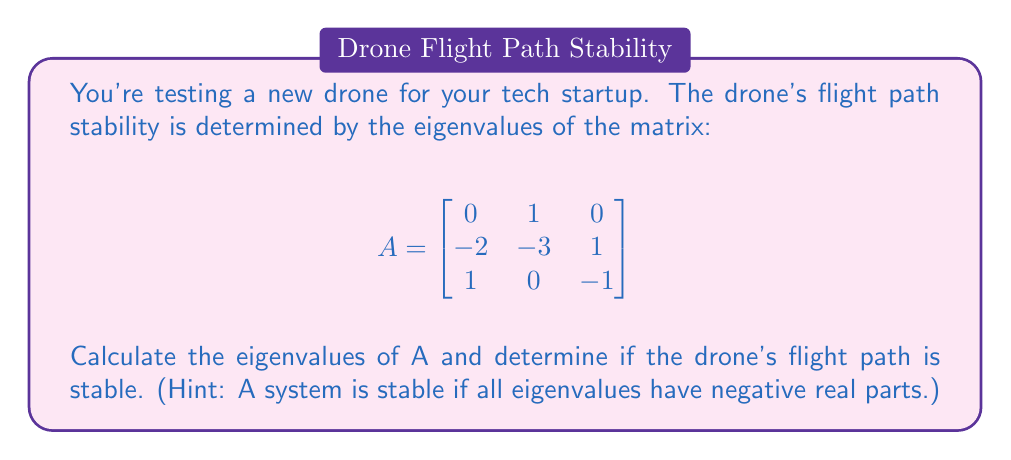Can you solve this math problem? To find the eigenvalues, we need to solve the characteristic equation:

$det(A - \lambda I) = 0$

1) First, let's set up the matrix $A - \lambda I$:

   $$A - \lambda I = \begin{bmatrix}
   -\lambda & 1 & 0 \\
   -2 & -3-\lambda & 1 \\
   1 & 0 & -1-\lambda
   \end{bmatrix}$$

2) Now, let's calculate the determinant:

   $det(A - \lambda I) = (-\lambda)((-3-\lambda)(-1-\lambda) - 1) - 1(-2(-1-\lambda) - 1(0))$
   
   $= -\lambda(3\lambda + \lambda^2 + 3 + \lambda - 1) + 2(-1-\lambda) + 0$
   
   $= -\lambda(\lambda^2 + 4\lambda + 2) - 2 - 2\lambda$
   
   $= -\lambda^3 - 4\lambda^2 - 2\lambda - 2 - 2\lambda$
   
   $= -\lambda^3 - 4\lambda^2 - 4\lambda - 2$

3) Set this equal to zero:

   $-\lambda^3 - 4\lambda^2 - 4\lambda - 2 = 0$

4) Factor out -1:

   $-(\lambda^3 + 4\lambda^2 + 4\lambda + 2) = 0$

5) Solve this equation. One real root is obvious: $\lambda = -2$

6) The other two roots can be found by factoring the remaining quadratic:

   $\lambda^2 + 2\lambda + 1 = (\lambda + 1)^2 = 0$

   So, $\lambda = -1$ (with multiplicity 2)

7) Therefore, the eigenvalues are: $\lambda_1 = -2$, $\lambda_2 = \lambda_3 = -1$

8) Since all eigenvalues have negative real parts, the system is stable.
Answer: Eigenvalues: -2, -1, -1; System is stable 